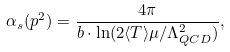<formula> <loc_0><loc_0><loc_500><loc_500>\alpha _ { s } ( p ^ { 2 } ) = \frac { 4 \pi } { b \cdot \ln ( 2 \langle T \rangle \mu / \Lambda _ { Q C D } ^ { 2 } ) } ,</formula> 